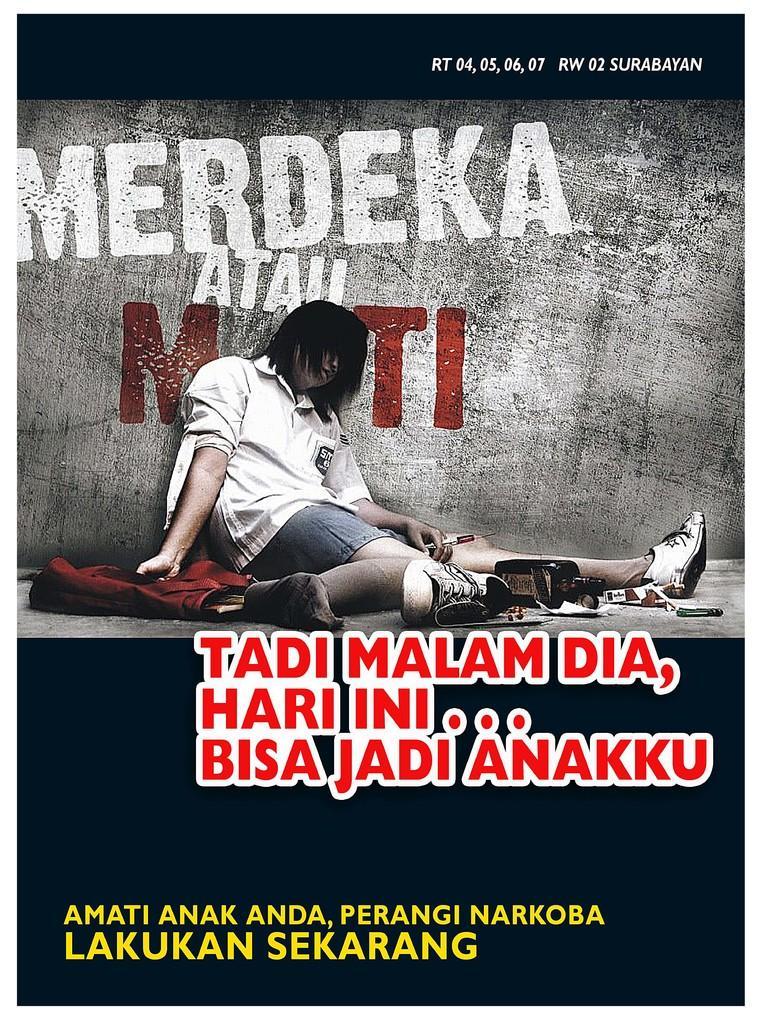Can you describe this image briefly? We can see poster,on this poster we can see a person sitting,behind this person we can see wall and we can see cloth and text. 